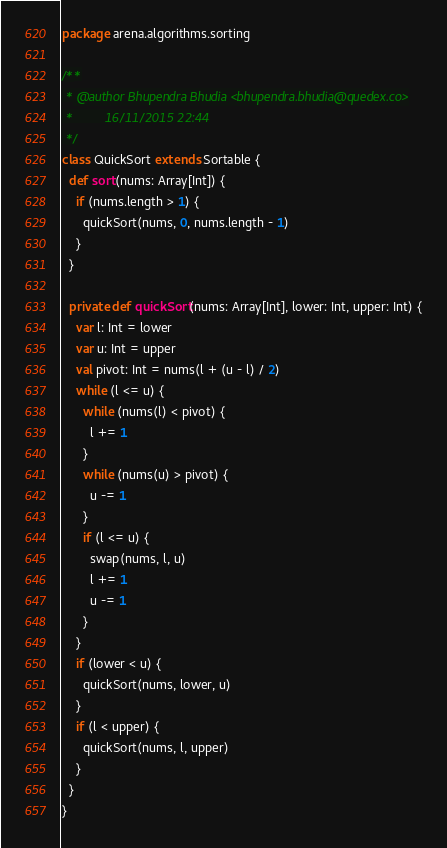Convert code to text. <code><loc_0><loc_0><loc_500><loc_500><_Scala_>package arena.algorithms.sorting

/**
 * @author Bhupendra Bhudia <bhupendra.bhudia@quedex.co>
 *         16/11/2015 22:44
 */
class QuickSort extends Sortable {
  def sort(nums: Array[Int]) {
    if (nums.length > 1) {
      quickSort(nums, 0, nums.length - 1)
    }
  }

  private def quickSort(nums: Array[Int], lower: Int, upper: Int) {
    var l: Int = lower
    var u: Int = upper
    val pivot: Int = nums(l + (u - l) / 2)
    while (l <= u) {
      while (nums(l) < pivot) {
        l += 1
      }
      while (nums(u) > pivot) {
        u -= 1
      }
      if (l <= u) {
        swap(nums, l, u)
        l += 1
        u -= 1
      }
    }
    if (lower < u) {
      quickSort(nums, lower, u)
    }
    if (l < upper) {
      quickSort(nums, l, upper)
    }
  }
}

</code> 